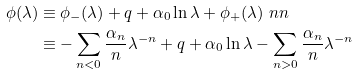Convert formula to latex. <formula><loc_0><loc_0><loc_500><loc_500>\phi ( \lambda ) & \equiv \phi _ { - } ( \lambda ) + q + \alpha _ { 0 } \ln \lambda + \phi _ { + } ( \lambda ) \ n n \\ & \equiv - \sum _ { n < 0 } \frac { \alpha _ { n } } { n } \lambda ^ { - n } + q + \alpha _ { 0 } \ln \lambda - \sum _ { n > 0 } \frac { \alpha _ { n } } { n } \lambda ^ { - n }</formula> 